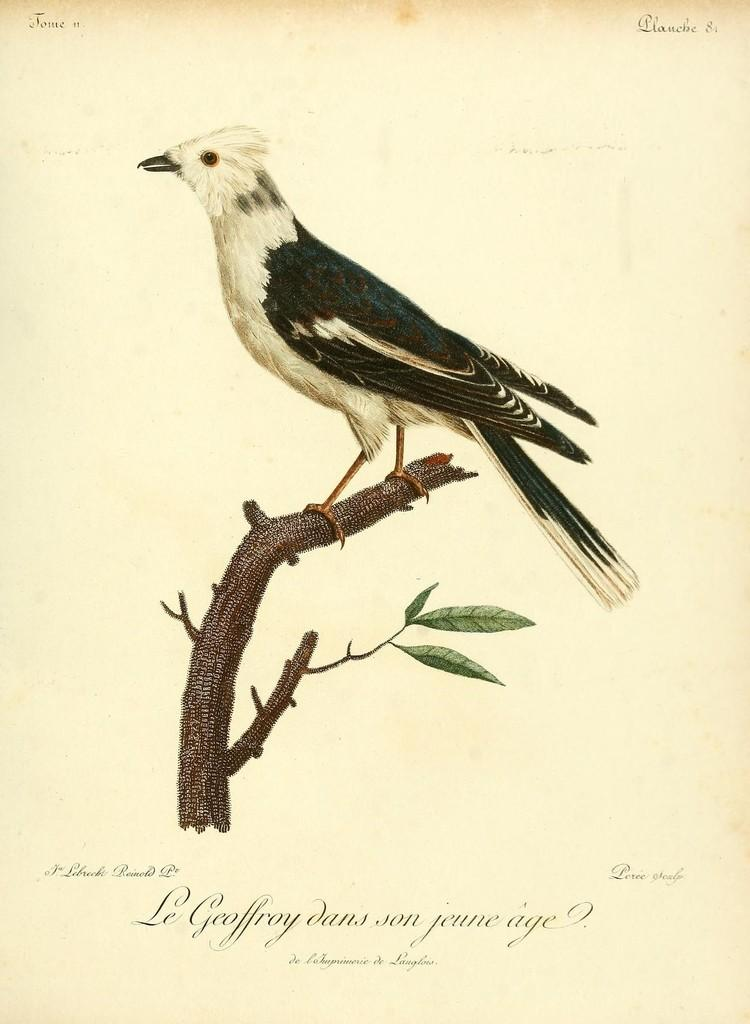What is the main subject of the picture? The main subject of the picture is a bird. Where is the bird located in the image? The bird is sitting on the branch of a tree. What is the medium of the image? The image is on a paper. What additional text is present below the image? There is a quote written below the image. How does the bird start the expansion process in the image? There is no indication in the image that the bird is involved in an expansion process. 